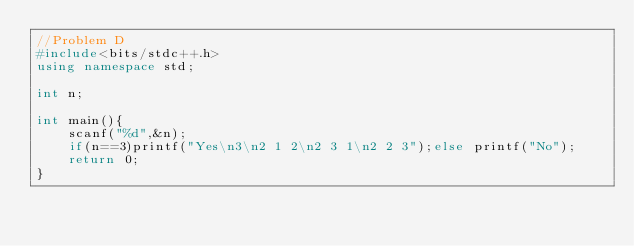<code> <loc_0><loc_0><loc_500><loc_500><_C++_>//Problem D
#include<bits/stdc++.h>
using namespace std;

int n;

int main(){
    scanf("%d",&n);
    if(n==3)printf("Yes\n3\n2 1 2\n2 3 1\n2 2 3");else printf("No");
    return 0;
}</code> 